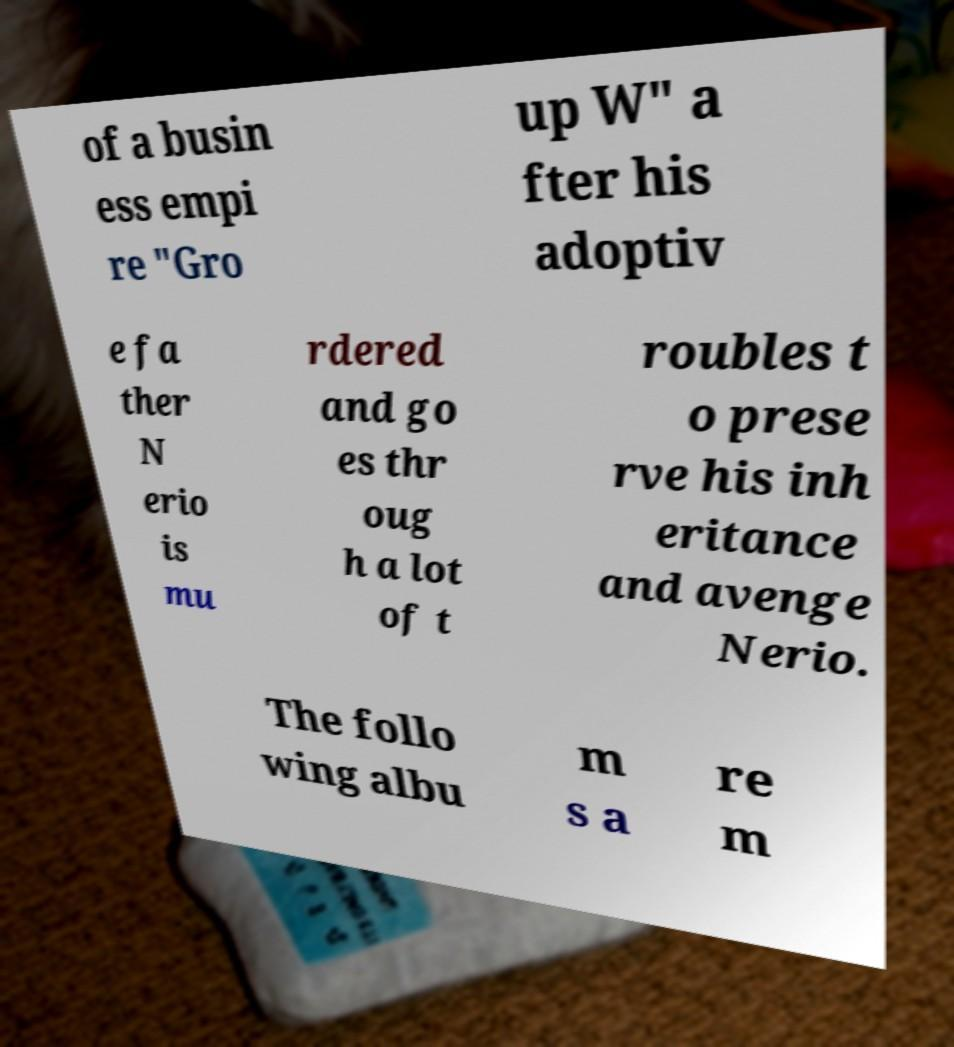Please identify and transcribe the text found in this image. of a busin ess empi re "Gro up W" a fter his adoptiv e fa ther N erio is mu rdered and go es thr oug h a lot of t roubles t o prese rve his inh eritance and avenge Nerio. The follo wing albu m s a re m 